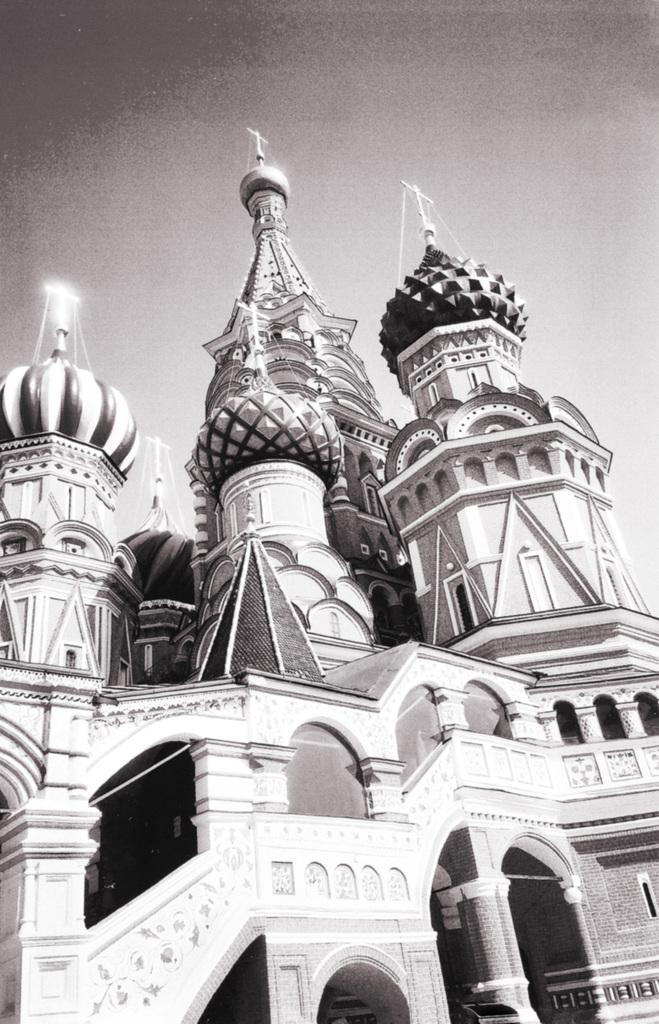What structure is present in the image? There is a building in the image. What part of the natural environment is visible in the image? The sky is visible in the background of the image. What type of good-bye is being said in the image? There is no indication of anyone saying good-bye in the image. What process is being depicted in the image? There is no process being depicted in the image; it simply shows a building and the sky. 